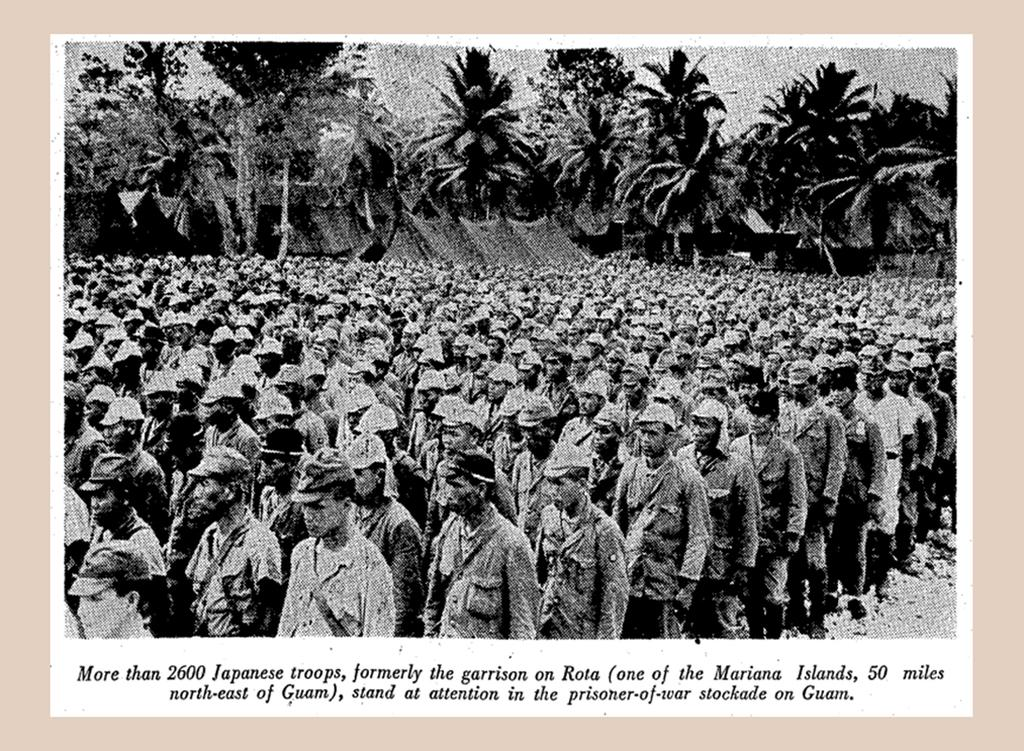<image>
Present a compact description of the photo's key features. a beige framed picture that says 'more than 2600' on it 